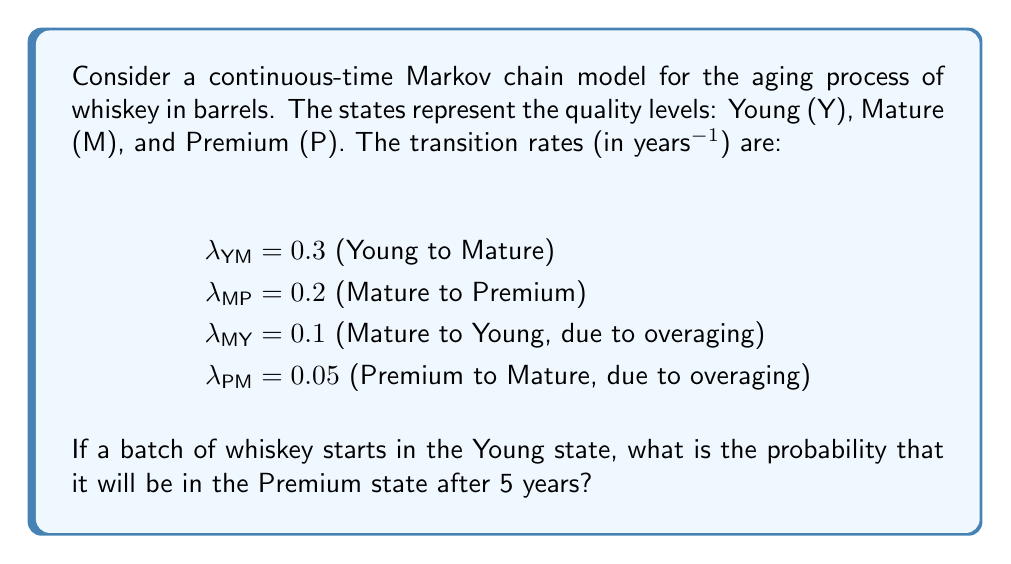Can you answer this question? To solve this problem, we need to use the continuous-time Markov chain transition probability matrix. Let's approach this step-by-step:

1) First, we need to set up the transition rate matrix Q:

   $$Q = \begin{bmatrix}
   -0.3 & 0.3 & 0 \\
   0.1 & -0.3 & 0.2 \\
   0 & 0.05 & -0.05
   \end{bmatrix}$$

2) The transition probability matrix after time t is given by:

   $$P(t) = e^{Qt}$$

3) We need to calculate P(5). This can be done using the matrix exponential:

   $$P(5) = e^{5Q}$$

4) To compute this, we can use the eigendecomposition method:

   $$e^{5Q} = S e^{5D} S^{-1}$$

   where D is a diagonal matrix of eigenvalues and S is a matrix of the corresponding eigenvectors.

5) Calculating the eigenvalues and eigenvectors (this step typically requires computational software):

   Eigenvalues: λ₁ ≈ -0.4142, λ₂ ≈ -0.1858, λ₃ = 0

6) After computing the full matrix P(5), we're interested in the entry P_YP(5), which is the probability of transitioning from Young to Premium in 5 years.

7) The result of this computation gives:

   $$P_YP(5) ≈ 0.2769$$

Therefore, the probability that the whiskey will be in the Premium state after 5 years, given that it started in the Young state, is approximately 0.2769 or 27.69%.
Answer: 0.2769 